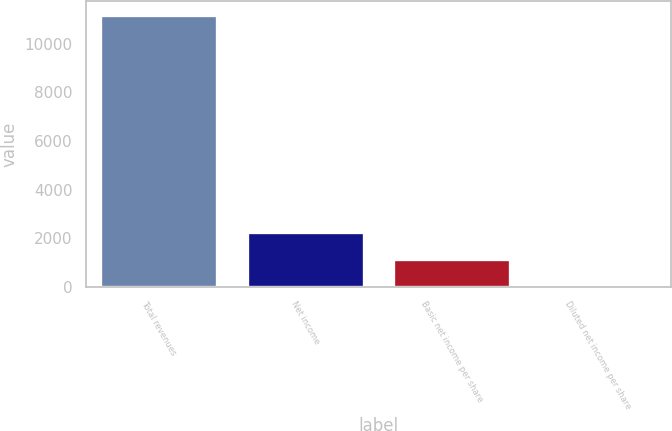Convert chart to OTSL. <chart><loc_0><loc_0><loc_500><loc_500><bar_chart><fcel>Total revenues<fcel>Net income<fcel>Basic net income per share<fcel>Diluted net income per share<nl><fcel>11192.2<fcel>2241.52<fcel>1122.69<fcel>3.86<nl></chart> 